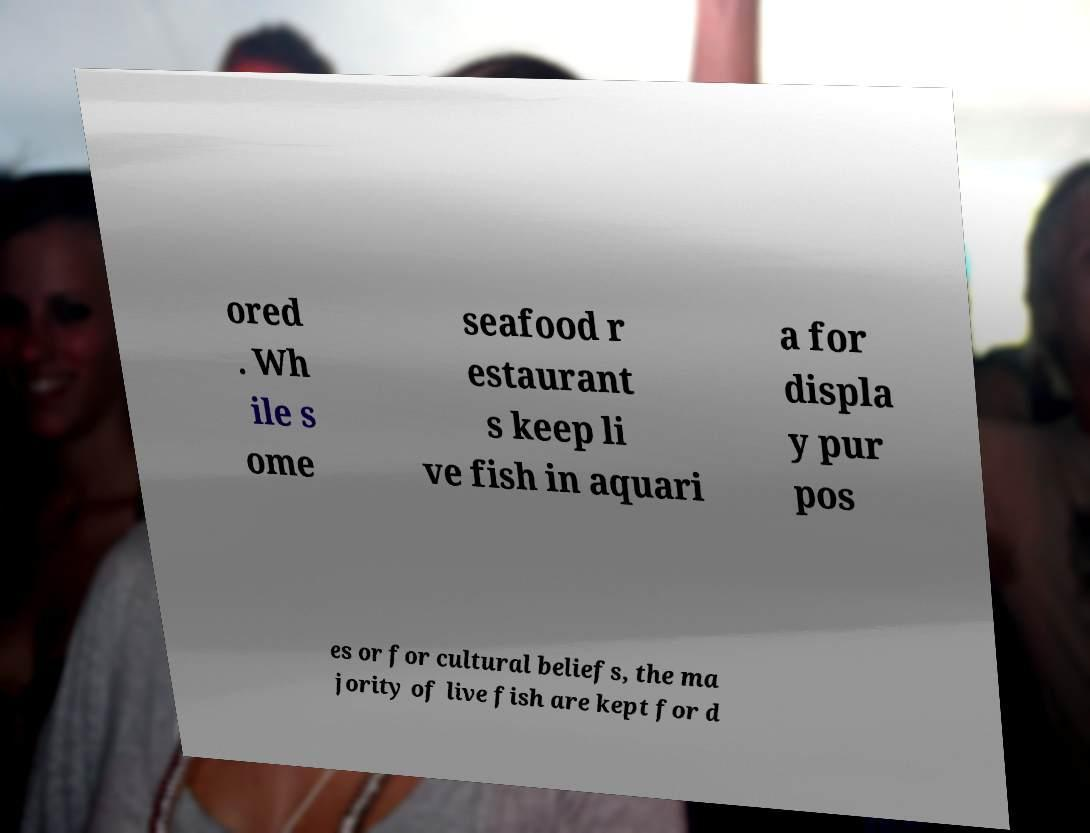What messages or text are displayed in this image? I need them in a readable, typed format. ored . Wh ile s ome seafood r estaurant s keep li ve fish in aquari a for displa y pur pos es or for cultural beliefs, the ma jority of live fish are kept for d 